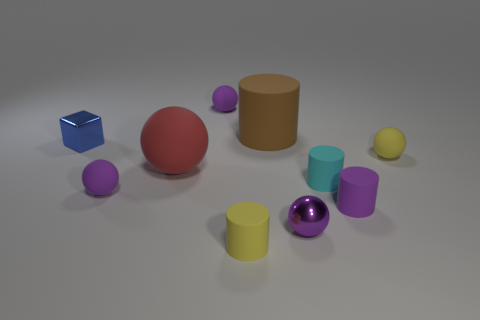What is the thing to the left of the purple rubber sphere in front of the small yellow rubber ball made of?
Make the answer very short. Metal. There is a blue cube that is the same size as the purple matte cylinder; what is its material?
Make the answer very short. Metal. There is a purple matte object behind the red matte sphere; does it have the same size as the small yellow cylinder?
Ensure brevity in your answer.  Yes. Does the small object that is behind the large brown rubber thing have the same shape as the big red thing?
Ensure brevity in your answer.  Yes. How many objects are red matte spheres or tiny balls to the right of the small metal sphere?
Offer a terse response. 2. Is the number of tiny yellow matte objects less than the number of big brown things?
Your response must be concise. No. Is the number of large red spheres greater than the number of tiny red rubber cylinders?
Your answer should be very brief. Yes. What number of other things are there of the same material as the block
Keep it short and to the point. 1. What number of large red matte things are behind the small yellow matte object on the right side of the small yellow object that is on the left side of the small cyan matte object?
Provide a short and direct response. 0. How many metal things are tiny purple objects or blue things?
Offer a very short reply. 2. 